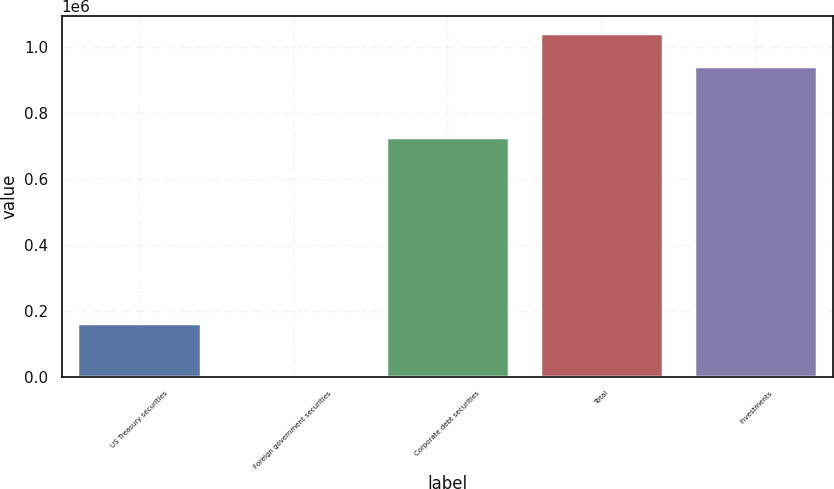Convert chart to OTSL. <chart><loc_0><loc_0><loc_500><loc_500><bar_chart><fcel>US Treasury securities<fcel>Foreign government securities<fcel>Corporate debt securities<fcel>Total<fcel>Investments<nl><fcel>164619<fcel>3486<fcel>725778<fcel>1.04189e+06<fcel>941989<nl></chart> 